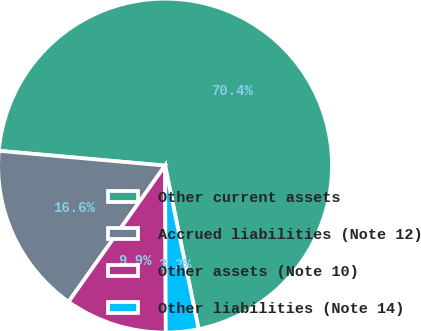<chart> <loc_0><loc_0><loc_500><loc_500><pie_chart><fcel>Other current assets<fcel>Accrued liabilities (Note 12)<fcel>Other assets (Note 10)<fcel>Other liabilities (Note 14)<nl><fcel>70.37%<fcel>16.6%<fcel>9.88%<fcel>3.15%<nl></chart> 